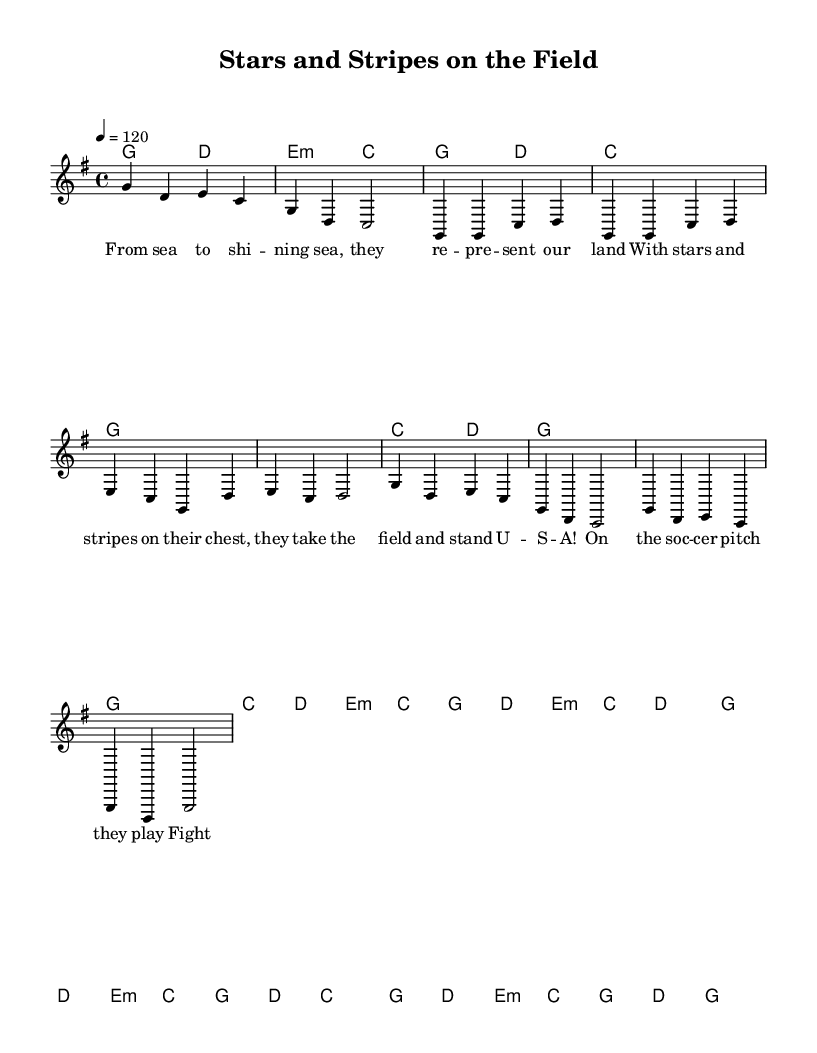What is the key signature of this music? The key signature is G major, which has one sharp (F#). It can be identified at the beginning of the score, where the key signature is indicated.
Answer: G major What is the time signature of this music? The time signature is 4/4, which means there are four beats in each measure, and a quarter note receives one beat. This is indicated in the score at the beginning, where the time signature is shown.
Answer: 4/4 What is the tempo marking indicated in the music? The tempo marking is 120 beats per minute. This can be found in the score as it provides guidance on the speed at which the piece should be played.
Answer: 120 How many measures are in the verse section of the song? The verse section contains a total of eight measures. This can be determined by counting the measures indicated in the melody part where the lyrics are aligned with the notes.
Answer: Eight What are the two main themes of the lyrics? The two main themes of the lyrics are representation and glory, as the lyrics celebrate the U.S. Women's National Soccer Team and their representation of the country during games. This can be inferred from the content of the lyrics both in the verse and chorus.
Answer: Representation and glory Which chord is played at the beginning of the chorus? The chord played at the beginning of the chorus is G. This can be found in the harmonies section where the chords are notated in relation to the melody starting the chorus.
Answer: G What type of song structure is used in this piece? This piece uses a verse-chorus structure, which is common in country rock music. This can be identified by the distinct sections - the verse followed by the chorus that repeats throughout the song.
Answer: Verse-chorus 